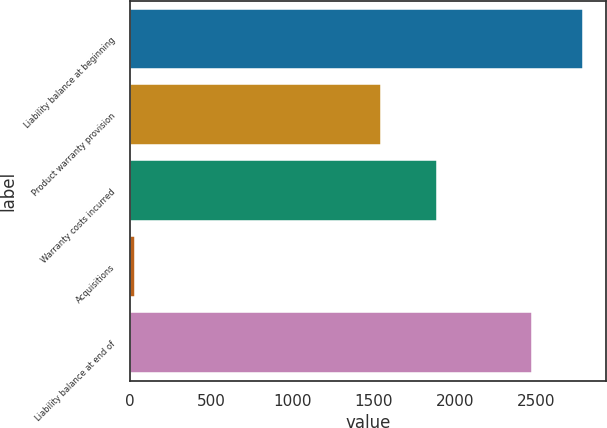<chart> <loc_0><loc_0><loc_500><loc_500><bar_chart><fcel>Liability balance at beginning<fcel>Product warranty provision<fcel>Warranty costs incurred<fcel>Acquisitions<fcel>Liability balance at end of<nl><fcel>2789<fcel>1541<fcel>1890<fcel>32<fcel>2472<nl></chart> 